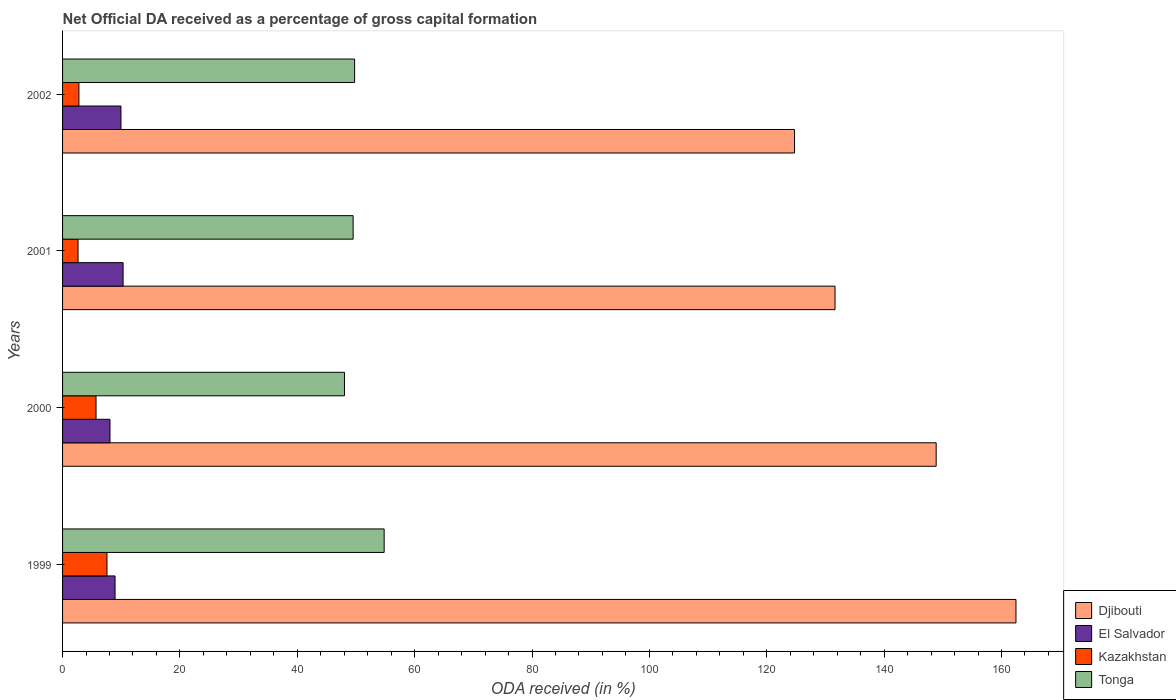How many groups of bars are there?
Make the answer very short. 4. Are the number of bars per tick equal to the number of legend labels?
Make the answer very short. Yes. Are the number of bars on each tick of the Y-axis equal?
Your answer should be compact. Yes. How many bars are there on the 3rd tick from the bottom?
Ensure brevity in your answer.  4. In how many cases, is the number of bars for a given year not equal to the number of legend labels?
Offer a terse response. 0. What is the net ODA received in Djibouti in 2001?
Provide a succinct answer. 131.64. Across all years, what is the maximum net ODA received in Tonga?
Offer a very short reply. 54.8. Across all years, what is the minimum net ODA received in El Salvador?
Offer a very short reply. 8.08. In which year was the net ODA received in El Salvador minimum?
Give a very brief answer. 2000. What is the total net ODA received in El Salvador in the graph?
Give a very brief answer. 37.29. What is the difference between the net ODA received in Djibouti in 2001 and that in 2002?
Your answer should be compact. 6.9. What is the difference between the net ODA received in Djibouti in 2001 and the net ODA received in Kazakhstan in 2002?
Give a very brief answer. 128.85. What is the average net ODA received in Djibouti per year?
Make the answer very short. 141.93. In the year 2001, what is the difference between the net ODA received in Djibouti and net ODA received in El Salvador?
Provide a succinct answer. 121.32. What is the ratio of the net ODA received in Kazakhstan in 1999 to that in 2002?
Keep it short and to the point. 2.71. Is the net ODA received in Djibouti in 2001 less than that in 2002?
Keep it short and to the point. No. What is the difference between the highest and the second highest net ODA received in Kazakhstan?
Keep it short and to the point. 1.87. What is the difference between the highest and the lowest net ODA received in Djibouti?
Ensure brevity in your answer.  37.73. Is the sum of the net ODA received in Djibouti in 1999 and 2002 greater than the maximum net ODA received in Tonga across all years?
Offer a terse response. Yes. What does the 2nd bar from the top in 1999 represents?
Keep it short and to the point. Kazakhstan. What does the 3rd bar from the bottom in 2002 represents?
Keep it short and to the point. Kazakhstan. Is it the case that in every year, the sum of the net ODA received in Djibouti and net ODA received in Kazakhstan is greater than the net ODA received in Tonga?
Keep it short and to the point. Yes. Are all the bars in the graph horizontal?
Your response must be concise. Yes. How many years are there in the graph?
Provide a succinct answer. 4. Does the graph contain grids?
Offer a terse response. No. Where does the legend appear in the graph?
Provide a short and direct response. Bottom right. How many legend labels are there?
Your response must be concise. 4. What is the title of the graph?
Offer a terse response. Net Official DA received as a percentage of gross capital formation. Does "Belgium" appear as one of the legend labels in the graph?
Ensure brevity in your answer.  No. What is the label or title of the X-axis?
Give a very brief answer. ODA received (in %). What is the ODA received (in %) of Djibouti in 1999?
Keep it short and to the point. 162.47. What is the ODA received (in %) of El Salvador in 1999?
Offer a terse response. 8.94. What is the ODA received (in %) of Kazakhstan in 1999?
Offer a terse response. 7.57. What is the ODA received (in %) of Tonga in 1999?
Your answer should be compact. 54.8. What is the ODA received (in %) in Djibouti in 2000?
Your answer should be very brief. 148.87. What is the ODA received (in %) of El Salvador in 2000?
Ensure brevity in your answer.  8.08. What is the ODA received (in %) in Kazakhstan in 2000?
Keep it short and to the point. 5.7. What is the ODA received (in %) of Tonga in 2000?
Your answer should be very brief. 48.04. What is the ODA received (in %) in Djibouti in 2001?
Provide a succinct answer. 131.64. What is the ODA received (in %) of El Salvador in 2001?
Make the answer very short. 10.31. What is the ODA received (in %) of Kazakhstan in 2001?
Provide a succinct answer. 2.64. What is the ODA received (in %) of Tonga in 2001?
Offer a very short reply. 49.51. What is the ODA received (in %) in Djibouti in 2002?
Give a very brief answer. 124.73. What is the ODA received (in %) in El Salvador in 2002?
Keep it short and to the point. 9.95. What is the ODA received (in %) in Kazakhstan in 2002?
Make the answer very short. 2.79. What is the ODA received (in %) of Tonga in 2002?
Your response must be concise. 49.77. Across all years, what is the maximum ODA received (in %) in Djibouti?
Provide a short and direct response. 162.47. Across all years, what is the maximum ODA received (in %) of El Salvador?
Offer a terse response. 10.31. Across all years, what is the maximum ODA received (in %) of Kazakhstan?
Provide a succinct answer. 7.57. Across all years, what is the maximum ODA received (in %) of Tonga?
Give a very brief answer. 54.8. Across all years, what is the minimum ODA received (in %) of Djibouti?
Offer a terse response. 124.73. Across all years, what is the minimum ODA received (in %) in El Salvador?
Provide a succinct answer. 8.08. Across all years, what is the minimum ODA received (in %) of Kazakhstan?
Offer a very short reply. 2.64. Across all years, what is the minimum ODA received (in %) of Tonga?
Make the answer very short. 48.04. What is the total ODA received (in %) of Djibouti in the graph?
Your answer should be compact. 567.71. What is the total ODA received (in %) of El Salvador in the graph?
Your response must be concise. 37.29. What is the total ODA received (in %) in Kazakhstan in the graph?
Offer a terse response. 18.7. What is the total ODA received (in %) in Tonga in the graph?
Offer a terse response. 202.12. What is the difference between the ODA received (in %) in Djibouti in 1999 and that in 2000?
Keep it short and to the point. 13.6. What is the difference between the ODA received (in %) of El Salvador in 1999 and that in 2000?
Offer a very short reply. 0.86. What is the difference between the ODA received (in %) in Kazakhstan in 1999 and that in 2000?
Give a very brief answer. 1.87. What is the difference between the ODA received (in %) of Tonga in 1999 and that in 2000?
Keep it short and to the point. 6.76. What is the difference between the ODA received (in %) of Djibouti in 1999 and that in 2001?
Make the answer very short. 30.83. What is the difference between the ODA received (in %) in El Salvador in 1999 and that in 2001?
Make the answer very short. -1.37. What is the difference between the ODA received (in %) of Kazakhstan in 1999 and that in 2001?
Your answer should be very brief. 4.93. What is the difference between the ODA received (in %) of Tonga in 1999 and that in 2001?
Your answer should be very brief. 5.29. What is the difference between the ODA received (in %) in Djibouti in 1999 and that in 2002?
Your answer should be compact. 37.73. What is the difference between the ODA received (in %) of El Salvador in 1999 and that in 2002?
Ensure brevity in your answer.  -1.01. What is the difference between the ODA received (in %) of Kazakhstan in 1999 and that in 2002?
Offer a very short reply. 4.78. What is the difference between the ODA received (in %) in Tonga in 1999 and that in 2002?
Keep it short and to the point. 5.03. What is the difference between the ODA received (in %) in Djibouti in 2000 and that in 2001?
Provide a short and direct response. 17.23. What is the difference between the ODA received (in %) in El Salvador in 2000 and that in 2001?
Your response must be concise. -2.23. What is the difference between the ODA received (in %) in Kazakhstan in 2000 and that in 2001?
Offer a very short reply. 3.06. What is the difference between the ODA received (in %) in Tonga in 2000 and that in 2001?
Offer a terse response. -1.48. What is the difference between the ODA received (in %) of Djibouti in 2000 and that in 2002?
Offer a very short reply. 24.13. What is the difference between the ODA received (in %) in El Salvador in 2000 and that in 2002?
Your response must be concise. -1.87. What is the difference between the ODA received (in %) of Kazakhstan in 2000 and that in 2002?
Provide a succinct answer. 2.91. What is the difference between the ODA received (in %) in Tonga in 2000 and that in 2002?
Make the answer very short. -1.73. What is the difference between the ODA received (in %) in Djibouti in 2001 and that in 2002?
Your answer should be very brief. 6.9. What is the difference between the ODA received (in %) in El Salvador in 2001 and that in 2002?
Provide a short and direct response. 0.36. What is the difference between the ODA received (in %) in Kazakhstan in 2001 and that in 2002?
Your answer should be very brief. -0.15. What is the difference between the ODA received (in %) in Tonga in 2001 and that in 2002?
Your answer should be compact. -0.25. What is the difference between the ODA received (in %) in Djibouti in 1999 and the ODA received (in %) in El Salvador in 2000?
Your answer should be compact. 154.39. What is the difference between the ODA received (in %) of Djibouti in 1999 and the ODA received (in %) of Kazakhstan in 2000?
Provide a short and direct response. 156.77. What is the difference between the ODA received (in %) in Djibouti in 1999 and the ODA received (in %) in Tonga in 2000?
Make the answer very short. 114.43. What is the difference between the ODA received (in %) of El Salvador in 1999 and the ODA received (in %) of Kazakhstan in 2000?
Your answer should be compact. 3.24. What is the difference between the ODA received (in %) in El Salvador in 1999 and the ODA received (in %) in Tonga in 2000?
Ensure brevity in your answer.  -39.1. What is the difference between the ODA received (in %) of Kazakhstan in 1999 and the ODA received (in %) of Tonga in 2000?
Give a very brief answer. -40.47. What is the difference between the ODA received (in %) of Djibouti in 1999 and the ODA received (in %) of El Salvador in 2001?
Your answer should be compact. 152.15. What is the difference between the ODA received (in %) of Djibouti in 1999 and the ODA received (in %) of Kazakhstan in 2001?
Your response must be concise. 159.83. What is the difference between the ODA received (in %) of Djibouti in 1999 and the ODA received (in %) of Tonga in 2001?
Provide a short and direct response. 112.95. What is the difference between the ODA received (in %) of El Salvador in 1999 and the ODA received (in %) of Kazakhstan in 2001?
Offer a very short reply. 6.31. What is the difference between the ODA received (in %) in El Salvador in 1999 and the ODA received (in %) in Tonga in 2001?
Provide a succinct answer. -40.57. What is the difference between the ODA received (in %) in Kazakhstan in 1999 and the ODA received (in %) in Tonga in 2001?
Offer a terse response. -41.95. What is the difference between the ODA received (in %) in Djibouti in 1999 and the ODA received (in %) in El Salvador in 2002?
Keep it short and to the point. 152.52. What is the difference between the ODA received (in %) of Djibouti in 1999 and the ODA received (in %) of Kazakhstan in 2002?
Offer a terse response. 159.68. What is the difference between the ODA received (in %) of Djibouti in 1999 and the ODA received (in %) of Tonga in 2002?
Ensure brevity in your answer.  112.7. What is the difference between the ODA received (in %) in El Salvador in 1999 and the ODA received (in %) in Kazakhstan in 2002?
Keep it short and to the point. 6.15. What is the difference between the ODA received (in %) of El Salvador in 1999 and the ODA received (in %) of Tonga in 2002?
Your response must be concise. -40.83. What is the difference between the ODA received (in %) of Kazakhstan in 1999 and the ODA received (in %) of Tonga in 2002?
Your answer should be very brief. -42.2. What is the difference between the ODA received (in %) in Djibouti in 2000 and the ODA received (in %) in El Salvador in 2001?
Ensure brevity in your answer.  138.55. What is the difference between the ODA received (in %) in Djibouti in 2000 and the ODA received (in %) in Kazakhstan in 2001?
Keep it short and to the point. 146.23. What is the difference between the ODA received (in %) of Djibouti in 2000 and the ODA received (in %) of Tonga in 2001?
Offer a terse response. 99.36. What is the difference between the ODA received (in %) in El Salvador in 2000 and the ODA received (in %) in Kazakhstan in 2001?
Provide a short and direct response. 5.44. What is the difference between the ODA received (in %) in El Salvador in 2000 and the ODA received (in %) in Tonga in 2001?
Make the answer very short. -41.43. What is the difference between the ODA received (in %) of Kazakhstan in 2000 and the ODA received (in %) of Tonga in 2001?
Keep it short and to the point. -43.81. What is the difference between the ODA received (in %) of Djibouti in 2000 and the ODA received (in %) of El Salvador in 2002?
Provide a short and direct response. 138.92. What is the difference between the ODA received (in %) of Djibouti in 2000 and the ODA received (in %) of Kazakhstan in 2002?
Provide a short and direct response. 146.08. What is the difference between the ODA received (in %) of Djibouti in 2000 and the ODA received (in %) of Tonga in 2002?
Your answer should be compact. 99.1. What is the difference between the ODA received (in %) of El Salvador in 2000 and the ODA received (in %) of Kazakhstan in 2002?
Provide a short and direct response. 5.29. What is the difference between the ODA received (in %) in El Salvador in 2000 and the ODA received (in %) in Tonga in 2002?
Provide a short and direct response. -41.69. What is the difference between the ODA received (in %) in Kazakhstan in 2000 and the ODA received (in %) in Tonga in 2002?
Your response must be concise. -44.07. What is the difference between the ODA received (in %) in Djibouti in 2001 and the ODA received (in %) in El Salvador in 2002?
Provide a short and direct response. 121.68. What is the difference between the ODA received (in %) of Djibouti in 2001 and the ODA received (in %) of Kazakhstan in 2002?
Make the answer very short. 128.85. What is the difference between the ODA received (in %) of Djibouti in 2001 and the ODA received (in %) of Tonga in 2002?
Provide a short and direct response. 81.87. What is the difference between the ODA received (in %) in El Salvador in 2001 and the ODA received (in %) in Kazakhstan in 2002?
Make the answer very short. 7.53. What is the difference between the ODA received (in %) of El Salvador in 2001 and the ODA received (in %) of Tonga in 2002?
Provide a short and direct response. -39.45. What is the difference between the ODA received (in %) of Kazakhstan in 2001 and the ODA received (in %) of Tonga in 2002?
Provide a short and direct response. -47.13. What is the average ODA received (in %) in Djibouti per year?
Offer a very short reply. 141.93. What is the average ODA received (in %) in El Salvador per year?
Provide a succinct answer. 9.32. What is the average ODA received (in %) of Kazakhstan per year?
Make the answer very short. 4.67. What is the average ODA received (in %) of Tonga per year?
Keep it short and to the point. 50.53. In the year 1999, what is the difference between the ODA received (in %) in Djibouti and ODA received (in %) in El Salvador?
Your answer should be compact. 153.53. In the year 1999, what is the difference between the ODA received (in %) of Djibouti and ODA received (in %) of Kazakhstan?
Ensure brevity in your answer.  154.9. In the year 1999, what is the difference between the ODA received (in %) in Djibouti and ODA received (in %) in Tonga?
Your answer should be compact. 107.67. In the year 1999, what is the difference between the ODA received (in %) in El Salvador and ODA received (in %) in Kazakhstan?
Offer a terse response. 1.37. In the year 1999, what is the difference between the ODA received (in %) in El Salvador and ODA received (in %) in Tonga?
Your answer should be very brief. -45.86. In the year 1999, what is the difference between the ODA received (in %) in Kazakhstan and ODA received (in %) in Tonga?
Provide a succinct answer. -47.23. In the year 2000, what is the difference between the ODA received (in %) of Djibouti and ODA received (in %) of El Salvador?
Your answer should be very brief. 140.79. In the year 2000, what is the difference between the ODA received (in %) of Djibouti and ODA received (in %) of Kazakhstan?
Ensure brevity in your answer.  143.17. In the year 2000, what is the difference between the ODA received (in %) of Djibouti and ODA received (in %) of Tonga?
Provide a succinct answer. 100.83. In the year 2000, what is the difference between the ODA received (in %) in El Salvador and ODA received (in %) in Kazakhstan?
Provide a short and direct response. 2.38. In the year 2000, what is the difference between the ODA received (in %) in El Salvador and ODA received (in %) in Tonga?
Your answer should be compact. -39.96. In the year 2000, what is the difference between the ODA received (in %) in Kazakhstan and ODA received (in %) in Tonga?
Make the answer very short. -42.34. In the year 2001, what is the difference between the ODA received (in %) of Djibouti and ODA received (in %) of El Salvador?
Your response must be concise. 121.32. In the year 2001, what is the difference between the ODA received (in %) in Djibouti and ODA received (in %) in Kazakhstan?
Provide a short and direct response. 129. In the year 2001, what is the difference between the ODA received (in %) of Djibouti and ODA received (in %) of Tonga?
Your response must be concise. 82.12. In the year 2001, what is the difference between the ODA received (in %) in El Salvador and ODA received (in %) in Kazakhstan?
Give a very brief answer. 7.68. In the year 2001, what is the difference between the ODA received (in %) of El Salvador and ODA received (in %) of Tonga?
Provide a short and direct response. -39.2. In the year 2001, what is the difference between the ODA received (in %) of Kazakhstan and ODA received (in %) of Tonga?
Ensure brevity in your answer.  -46.88. In the year 2002, what is the difference between the ODA received (in %) of Djibouti and ODA received (in %) of El Salvador?
Provide a succinct answer. 114.78. In the year 2002, what is the difference between the ODA received (in %) in Djibouti and ODA received (in %) in Kazakhstan?
Keep it short and to the point. 121.95. In the year 2002, what is the difference between the ODA received (in %) in Djibouti and ODA received (in %) in Tonga?
Your answer should be compact. 74.97. In the year 2002, what is the difference between the ODA received (in %) of El Salvador and ODA received (in %) of Kazakhstan?
Offer a terse response. 7.16. In the year 2002, what is the difference between the ODA received (in %) of El Salvador and ODA received (in %) of Tonga?
Your answer should be very brief. -39.82. In the year 2002, what is the difference between the ODA received (in %) of Kazakhstan and ODA received (in %) of Tonga?
Offer a very short reply. -46.98. What is the ratio of the ODA received (in %) of Djibouti in 1999 to that in 2000?
Keep it short and to the point. 1.09. What is the ratio of the ODA received (in %) of El Salvador in 1999 to that in 2000?
Provide a succinct answer. 1.11. What is the ratio of the ODA received (in %) of Kazakhstan in 1999 to that in 2000?
Provide a succinct answer. 1.33. What is the ratio of the ODA received (in %) of Tonga in 1999 to that in 2000?
Offer a very short reply. 1.14. What is the ratio of the ODA received (in %) in Djibouti in 1999 to that in 2001?
Give a very brief answer. 1.23. What is the ratio of the ODA received (in %) in El Salvador in 1999 to that in 2001?
Your answer should be compact. 0.87. What is the ratio of the ODA received (in %) in Kazakhstan in 1999 to that in 2001?
Your response must be concise. 2.87. What is the ratio of the ODA received (in %) in Tonga in 1999 to that in 2001?
Offer a very short reply. 1.11. What is the ratio of the ODA received (in %) of Djibouti in 1999 to that in 2002?
Offer a very short reply. 1.3. What is the ratio of the ODA received (in %) in El Salvador in 1999 to that in 2002?
Give a very brief answer. 0.9. What is the ratio of the ODA received (in %) of Kazakhstan in 1999 to that in 2002?
Your answer should be very brief. 2.71. What is the ratio of the ODA received (in %) of Tonga in 1999 to that in 2002?
Provide a succinct answer. 1.1. What is the ratio of the ODA received (in %) of Djibouti in 2000 to that in 2001?
Your response must be concise. 1.13. What is the ratio of the ODA received (in %) in El Salvador in 2000 to that in 2001?
Make the answer very short. 0.78. What is the ratio of the ODA received (in %) of Kazakhstan in 2000 to that in 2001?
Keep it short and to the point. 2.16. What is the ratio of the ODA received (in %) in Tonga in 2000 to that in 2001?
Give a very brief answer. 0.97. What is the ratio of the ODA received (in %) in Djibouti in 2000 to that in 2002?
Provide a short and direct response. 1.19. What is the ratio of the ODA received (in %) in El Salvador in 2000 to that in 2002?
Keep it short and to the point. 0.81. What is the ratio of the ODA received (in %) of Kazakhstan in 2000 to that in 2002?
Your answer should be compact. 2.05. What is the ratio of the ODA received (in %) of Tonga in 2000 to that in 2002?
Provide a short and direct response. 0.97. What is the ratio of the ODA received (in %) of Djibouti in 2001 to that in 2002?
Give a very brief answer. 1.06. What is the ratio of the ODA received (in %) in El Salvador in 2001 to that in 2002?
Your answer should be very brief. 1.04. What is the ratio of the ODA received (in %) in Kazakhstan in 2001 to that in 2002?
Offer a very short reply. 0.95. What is the ratio of the ODA received (in %) of Tonga in 2001 to that in 2002?
Your answer should be compact. 0.99. What is the difference between the highest and the second highest ODA received (in %) of Djibouti?
Give a very brief answer. 13.6. What is the difference between the highest and the second highest ODA received (in %) in El Salvador?
Your answer should be compact. 0.36. What is the difference between the highest and the second highest ODA received (in %) of Kazakhstan?
Your response must be concise. 1.87. What is the difference between the highest and the second highest ODA received (in %) in Tonga?
Ensure brevity in your answer.  5.03. What is the difference between the highest and the lowest ODA received (in %) of Djibouti?
Offer a terse response. 37.73. What is the difference between the highest and the lowest ODA received (in %) in El Salvador?
Give a very brief answer. 2.23. What is the difference between the highest and the lowest ODA received (in %) of Kazakhstan?
Offer a very short reply. 4.93. What is the difference between the highest and the lowest ODA received (in %) in Tonga?
Make the answer very short. 6.76. 